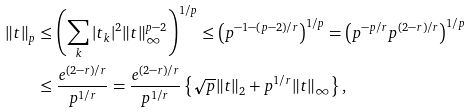<formula> <loc_0><loc_0><loc_500><loc_500>\| t \| _ { p } & \leq \left ( \sum _ { k } | t _ { k } | ^ { 2 } \| t \| _ { \infty } ^ { p - 2 } \right ) ^ { 1 / p } \leq \left ( p ^ { - 1 - ( p - 2 ) / r } \right ) ^ { 1 / p } = \left ( p ^ { - p / r } p ^ { ( 2 - r ) / r } \right ) ^ { 1 / p } \\ & \leq \frac { e ^ { ( 2 - r ) / r } } { p ^ { 1 / r } } = \frac { e ^ { ( 2 - r ) / r } } { p ^ { 1 / r } } \left \{ \sqrt { p } \| t \| _ { 2 } + p ^ { 1 / r } \| t \| _ { \infty } \right \} ,</formula> 